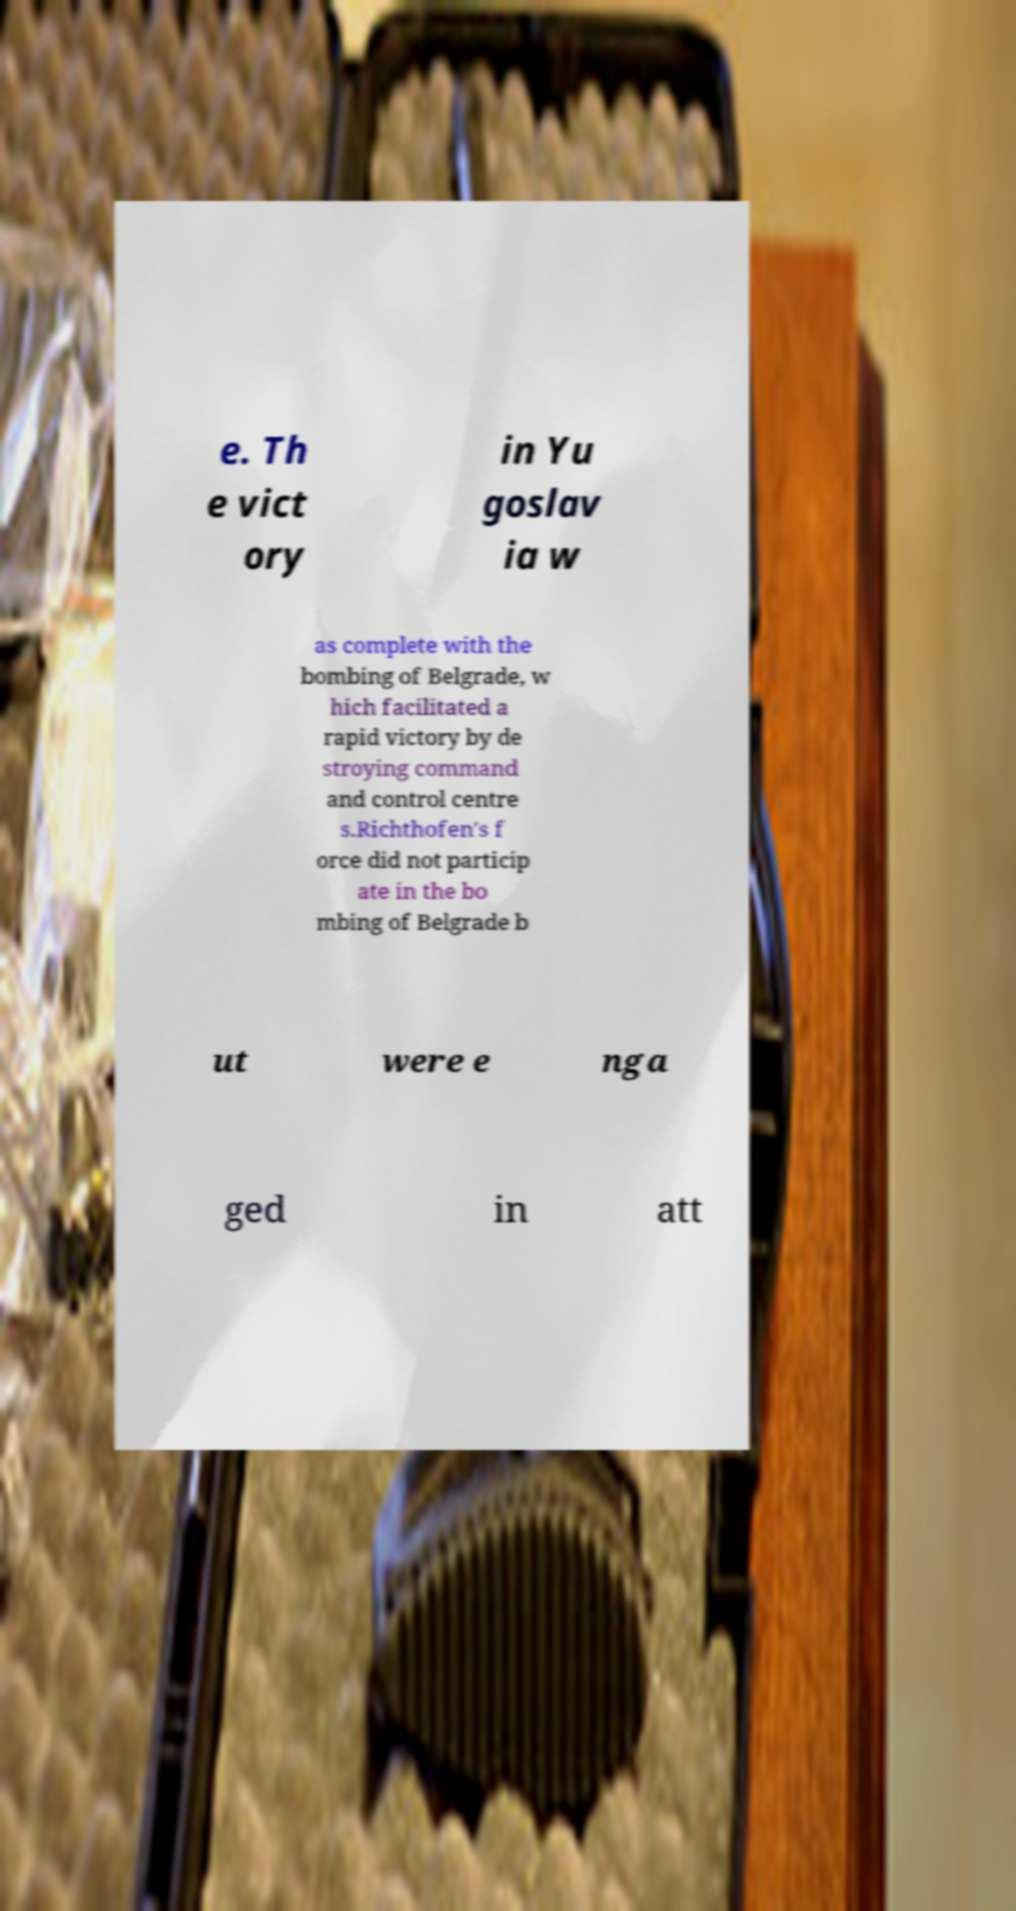Please identify and transcribe the text found in this image. e. Th e vict ory in Yu goslav ia w as complete with the bombing of Belgrade, w hich facilitated a rapid victory by de stroying command and control centre s.Richthofen's f orce did not particip ate in the bo mbing of Belgrade b ut were e nga ged in att 